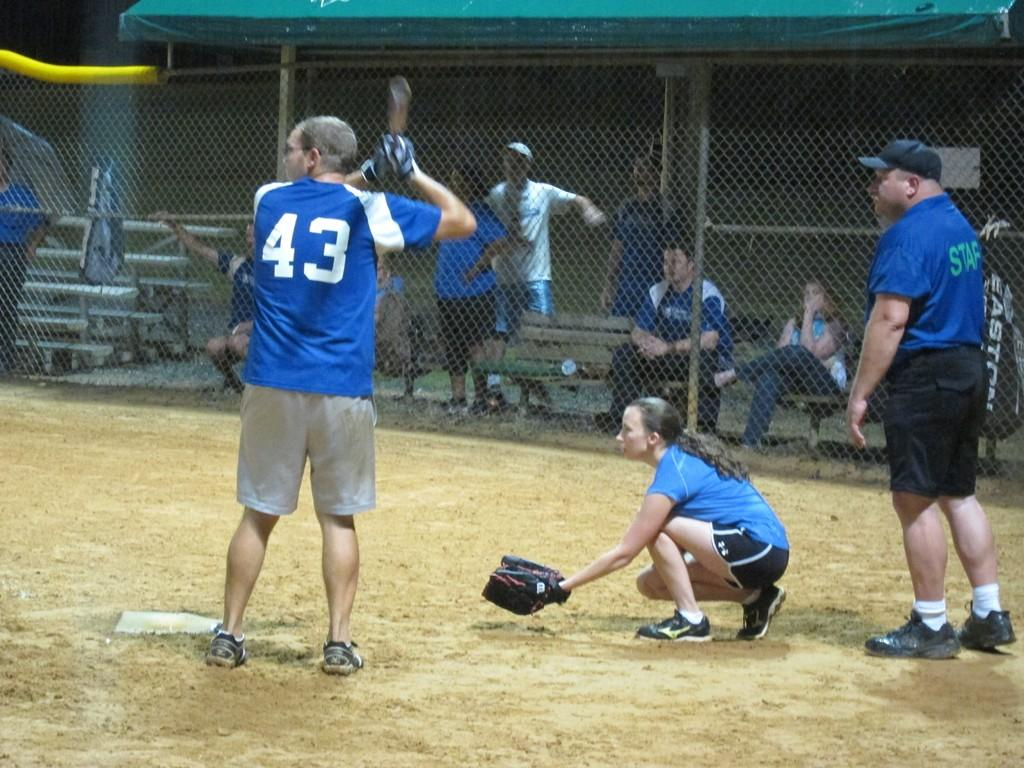<image>
Write a terse but informative summary of the picture. Man wearing number 43 getting ready to bat at a baseball game. 